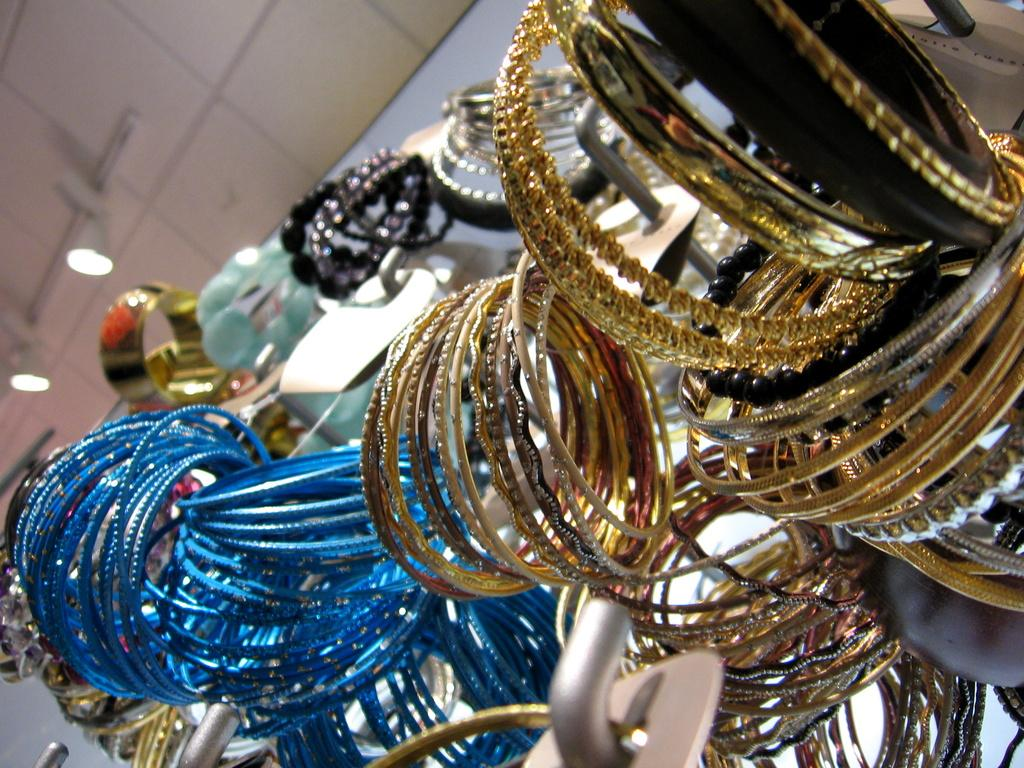What types of jewelry are visible in the image? There are different types of bangles in the image. What can be seen on the ceiling in the image? There are lights on the ceiling in the image. What type of breakfast is being served in the image? There is no breakfast visible in the image; it only features bangles and lights on the ceiling. 